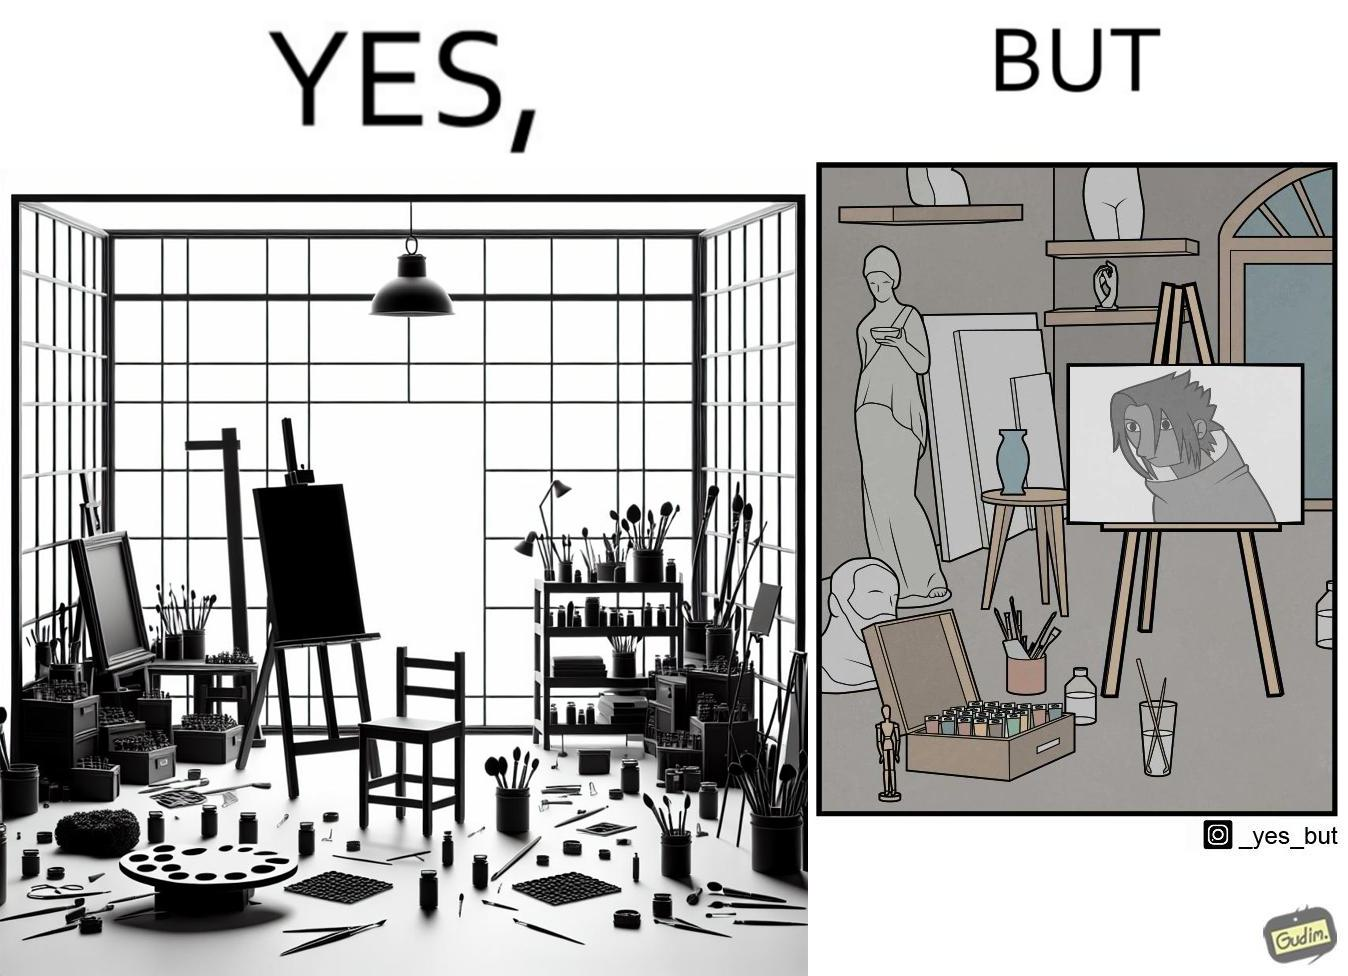Compare the left and right sides of this image. In the left part of the image: an art studio with a blank canvas. In the right part of the image: an art studio with a black and white painting on a canvas. 